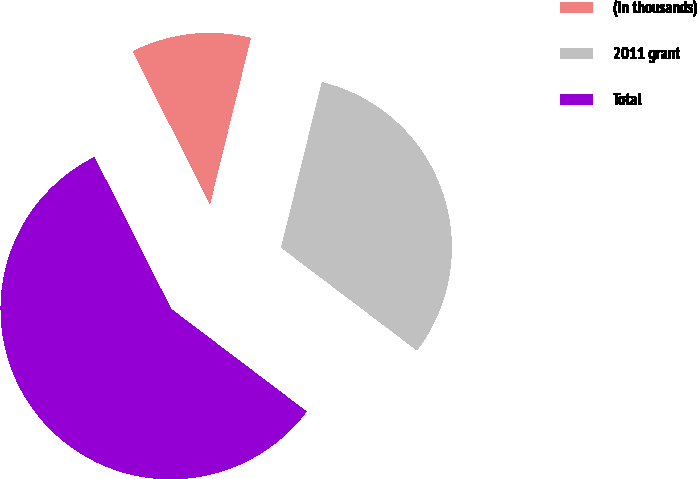<chart> <loc_0><loc_0><loc_500><loc_500><pie_chart><fcel>(In thousands)<fcel>2011 grant<fcel>Total<nl><fcel>11.27%<fcel>31.48%<fcel>57.25%<nl></chart> 